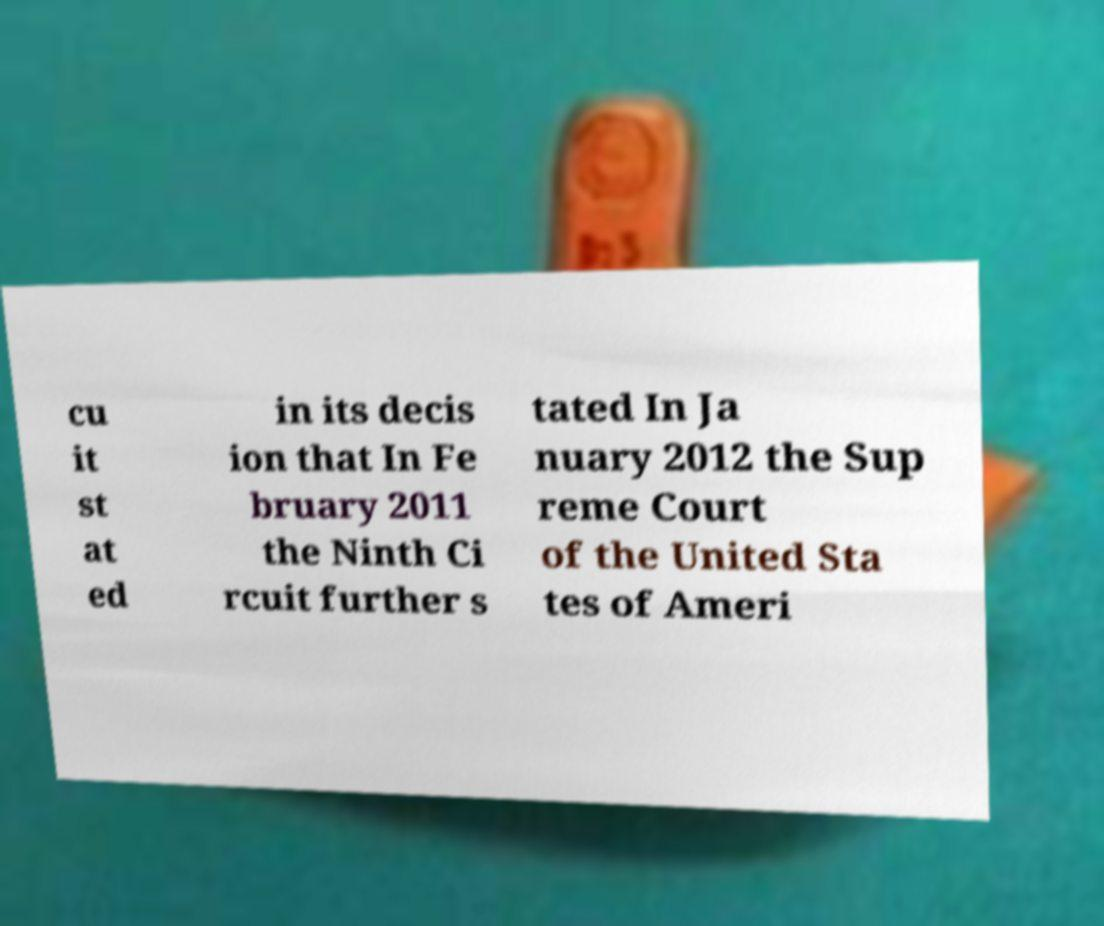There's text embedded in this image that I need extracted. Can you transcribe it verbatim? cu it st at ed in its decis ion that In Fe bruary 2011 the Ninth Ci rcuit further s tated In Ja nuary 2012 the Sup reme Court of the United Sta tes of Ameri 